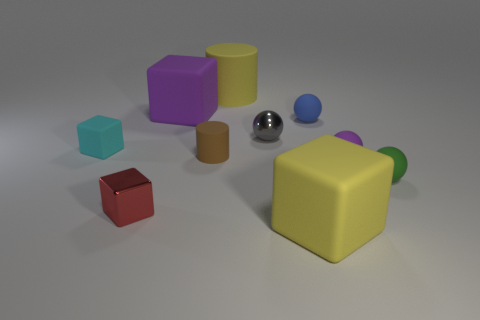What is the material of the large yellow block?
Provide a short and direct response. Rubber. Does the purple matte cube have the same size as the yellow rubber cylinder?
Your response must be concise. Yes. What number of cubes are small yellow rubber objects or large purple matte things?
Your answer should be compact. 1. There is a big rubber block that is left of the rubber block that is in front of the small red block; what color is it?
Your response must be concise. Purple. Is the number of purple matte objects left of the brown rubber cylinder less than the number of small cyan blocks that are in front of the small purple matte sphere?
Provide a short and direct response. No. Is the size of the yellow cube the same as the cyan matte cube that is left of the small metallic cube?
Make the answer very short. No. There is a tiny rubber object that is in front of the tiny matte cylinder and on the left side of the green matte object; what is its shape?
Offer a very short reply. Sphere. There is a purple cube that is the same material as the brown cylinder; what is its size?
Keep it short and to the point. Large. How many tiny cyan objects are on the left side of the shiny object that is in front of the small green rubber thing?
Your response must be concise. 1. Do the purple object in front of the brown matte object and the green thing have the same material?
Offer a very short reply. Yes. 